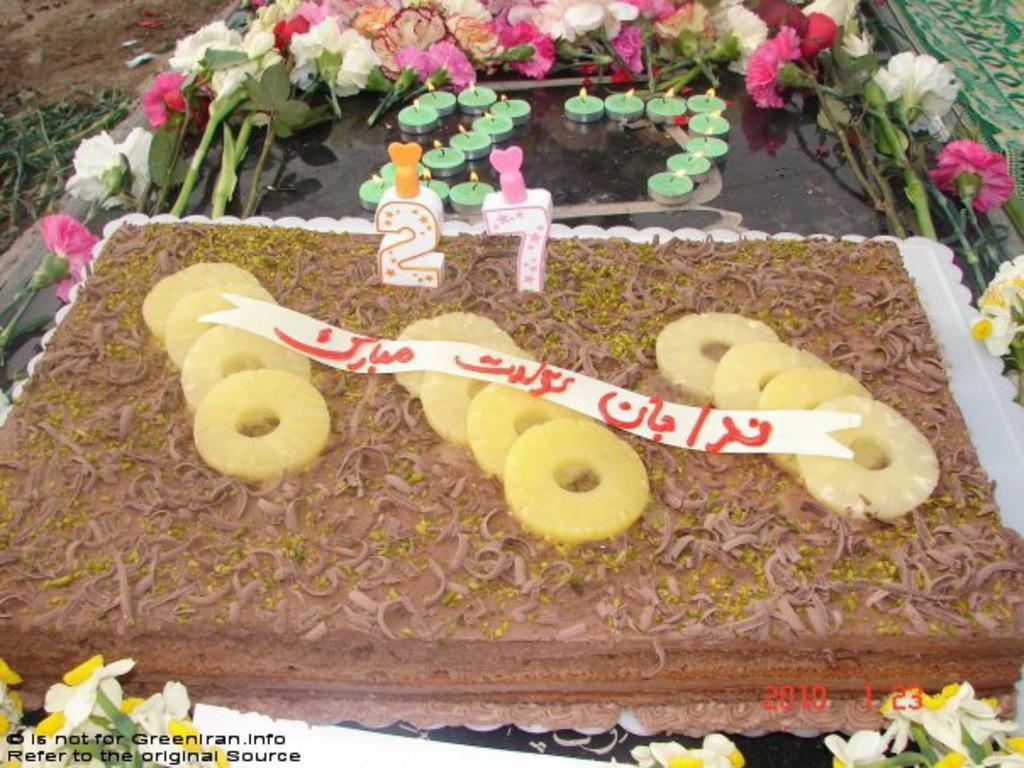How would you summarize this image in a sentence or two? In this image, I can see a cake, candles and flowers on an object. At the bottom of the image, there are watermarks. At the top left corner of the image, I can see the plants. 